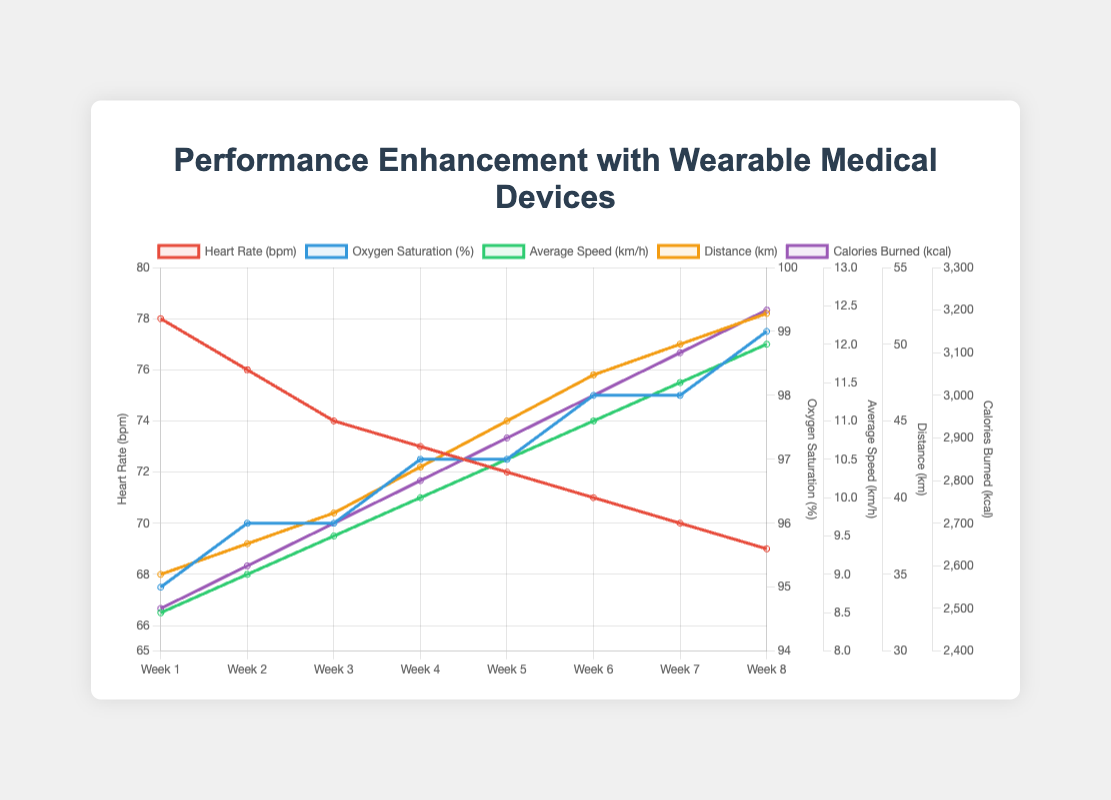Can you observe a trend in the heart rate over the 8 weeks? The heart rate appears to be gradually decreasing from Week 1 to Week 8. To identify the trend, observe the downward trajectory of the red line representing heart rate values in the figure.
Answer: Decreasing By how much did the average speed increase from Week 1 to Week 8? The average speed in Week 1 is 8.5 km/h and in Week 8 is 12.0 km/h. The increase can be calculated as 12.0 - 8.5 = 3.5 km/h.
Answer: 3.5 km/h Which parameter shows the most significant improvement over the training period? By comparing the visual steepness of all lines, the average speed (green), distance (orange), and calories burned (purple) show significant improvements. Average speed increases from 8.5 km/h to 12.0 km/h, distance from 35 km to 52 km, and calories burned from 2500 kcal to 3200 kcal. The distance improves by 17 km, which is the most significant among these.
Answer: Distance What is the difference in oxygen saturation between Week 3 and Week 6? The oxygen saturation in Week 3 is 96%, and in Week 6 it is 98%. The difference can be calculated as 98% - 96% = 2%.
Answer: 2% Which week shows the highest calories burned, and what is the value? The figure's purple line for calories burned shows its highest point in Week 8. The value for Week 8 is 3200 kcal.
Answer: Week 8, 3200 kcal Does the distance show a linear increase over the 8 weeks? Inspecting the orange line for distance over the 8 weeks, it seems to increase linearly with a regular, steady incline each week.
Answer: Yes Compare the heart rate in Week 1 and Week 8. Which week exhibits a lower heart rate? The heart rate in Week 1 is 78 bpm, and in Week 8 it is 69 bpm. By visual comparison of the red line, Week 8 exhibits a lower heart rate.
Answer: Week 8 By what percentage did the calories burned increase from Week 1 to Week 8? Week 1 has 2500 kcal and Week 8 has 3200 kcal. The percentage increase is calculated as ((3200 - 2500) / 2500) * 100 = 28%.
Answer: 28% Which parameter reaches the highest value in the plot? Observing the peaks of each line in the plot, the highest value reached is in the heart rate parameter (red line) at 78 bpm, in Week 1. However, the highest maximum value in terms of an increase is the distance at 52 km (orange line).
Answer: Heart rate, 78 bpm 